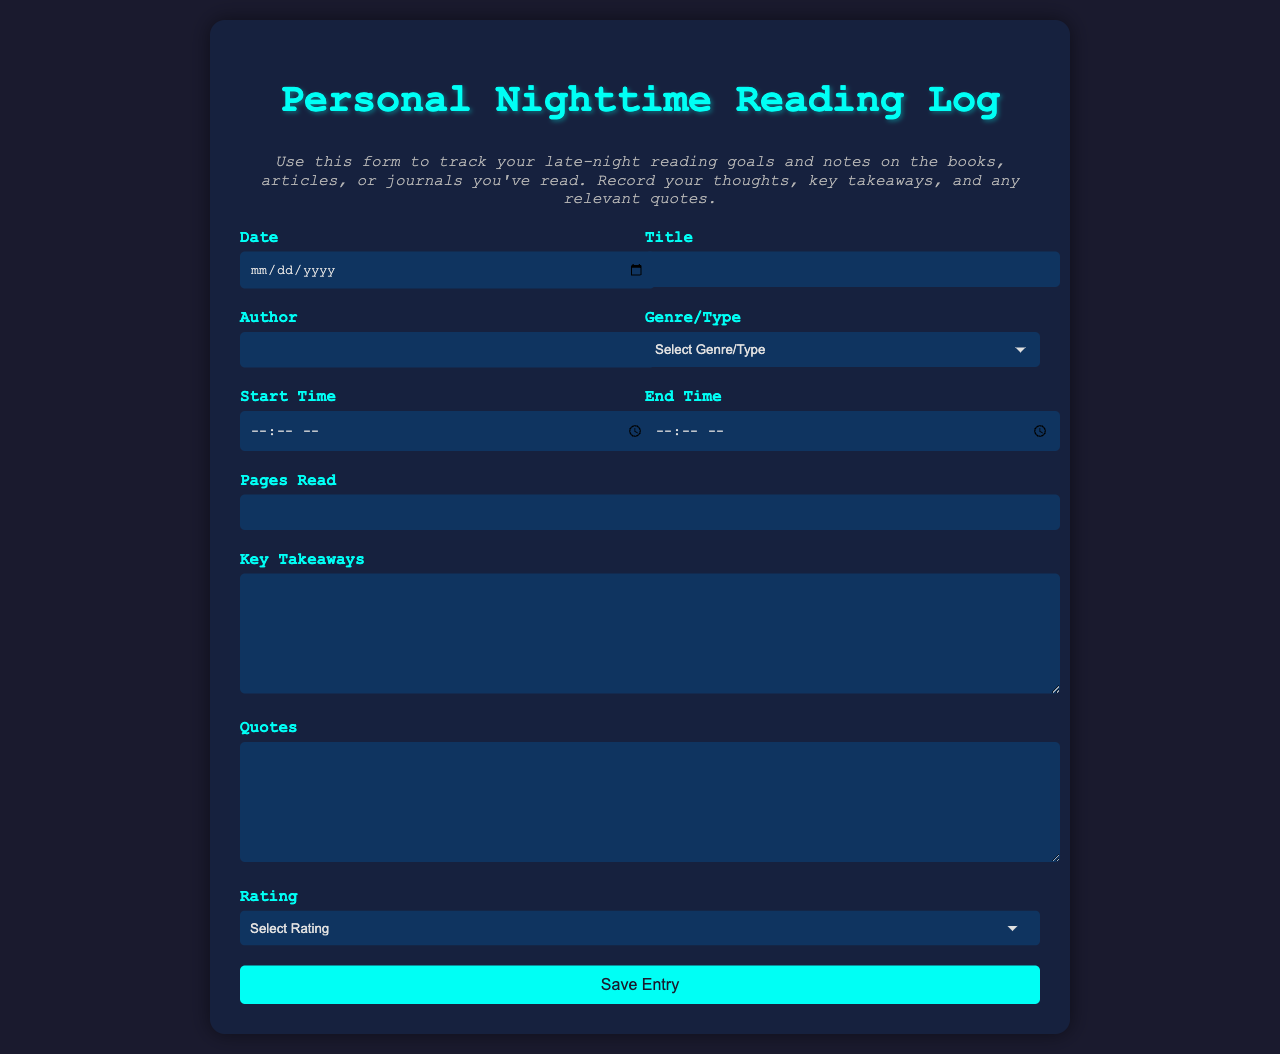what is the title of the form? The title of the form is prominently displayed at the top, indicating its purpose for tracking nighttime reading.
Answer: Personal Nighttime Reading Log what is the required minimum number of pages that can be read? The form specifies that participants must indicate a minimum number of pages read, and this is set to 1.
Answer: 1 what genre options are available in the form? The form includes multiple options for genre/type in a dropdown menu, allowing users to select their reading category.
Answer: Fiction, Non-Fiction, Biography, Science, Literature, Journal Article, Online Article what is the purpose of the 'Takeaways' section in the form? This section is designed for the user to capture key insights or important thoughts gathered from the reading material.
Answer: Key Takeaways how many star ratings can a book receive according to the form? The form allows users to rate their reading experience on a scale from 1 to 5 stars, as indicated in the rating dropdown.
Answer: 5 Stars what is the color scheme of the webpage? The color scheme combines dark background colors with light text colors to create a visually appealing and comfortable reading experience at night.
Answer: Dark background with light text what is the format of the 'Date' input in the form? The 'Date' field in the form specifically requests the user to input a date in a structured format that aligns with common date entries.
Answer: Date input format what time fields are required to be filled out in the form? Users need to fill out the start and end times of their reading sessions, as indicated by the respective fields in the form.
Answer: Start Time and End Time what type of feedback can a user provide through the 'Quotes' section? This section allows users to jot down any memorable quotes or passages from their reading material for later reference.
Answer: Quotes 